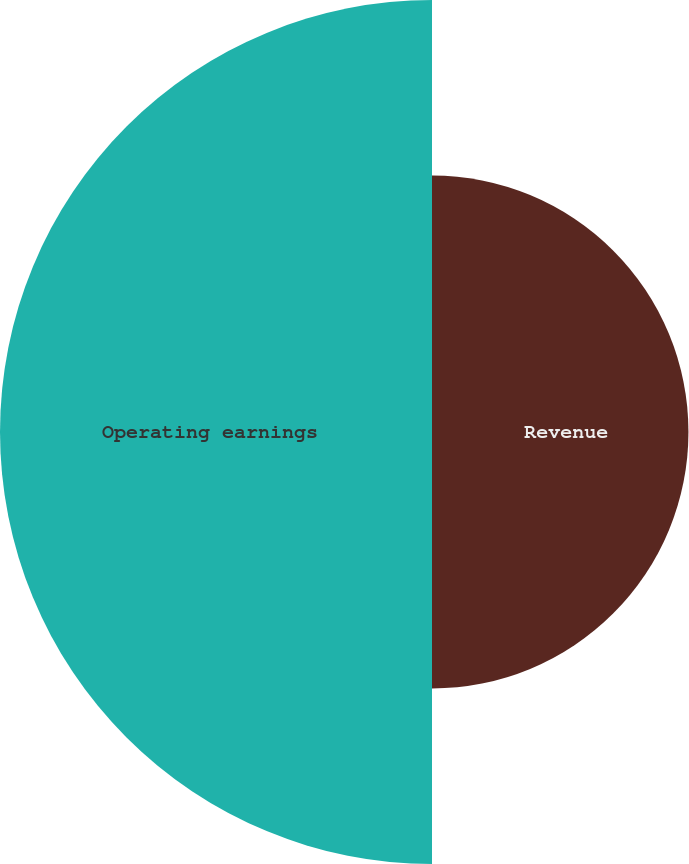Convert chart. <chart><loc_0><loc_0><loc_500><loc_500><pie_chart><fcel>Revenue<fcel>Operating earnings<nl><fcel>37.25%<fcel>62.75%<nl></chart> 